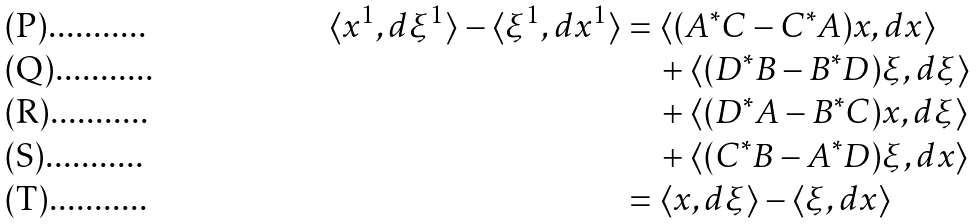<formula> <loc_0><loc_0><loc_500><loc_500>\langle x ^ { 1 } , d \xi ^ { 1 } \rangle - \langle \xi ^ { 1 } , d x ^ { 1 } \rangle & = \langle ( A ^ { * } C - C ^ { * } A ) x , d x \rangle \\ & \quad + \langle ( D ^ { * } B - B ^ { * } D ) \xi , d \xi \rangle \\ & \quad + \langle ( D ^ { * } A - B ^ { * } C ) x , d \xi \rangle \\ & \quad + \langle ( C ^ { * } B - A ^ { * } D ) \xi , d x \rangle \\ & = \langle x , d \xi \rangle - \langle \xi , d x \rangle</formula> 